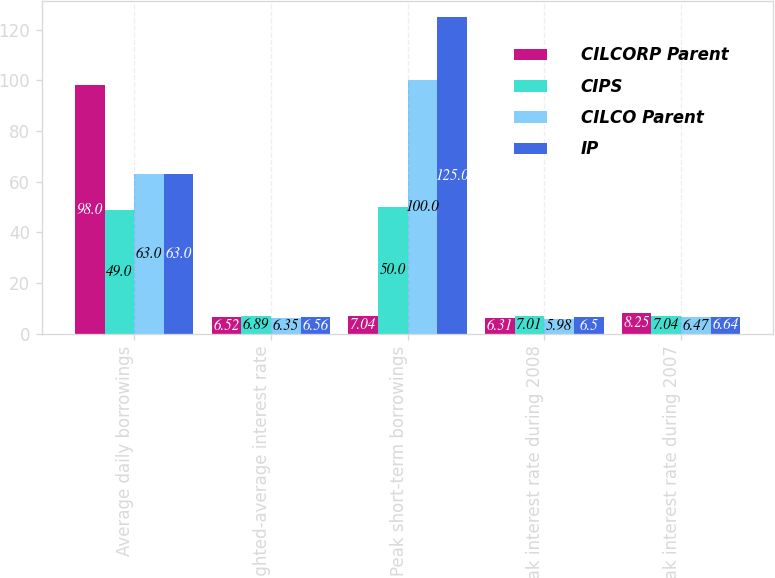<chart> <loc_0><loc_0><loc_500><loc_500><stacked_bar_chart><ecel><fcel>Average daily borrowings<fcel>Weighted-average interest rate<fcel>Peak short-term borrowings<fcel>Peak interest rate during 2008<fcel>Peak interest rate during 2007<nl><fcel>CILCORP Parent<fcel>98<fcel>6.52<fcel>7.04<fcel>6.31<fcel>8.25<nl><fcel>CIPS<fcel>49<fcel>6.89<fcel>50<fcel>7.01<fcel>7.04<nl><fcel>CILCO Parent<fcel>63<fcel>6.35<fcel>100<fcel>5.98<fcel>6.47<nl><fcel>IP<fcel>63<fcel>6.56<fcel>125<fcel>6.5<fcel>6.64<nl></chart> 